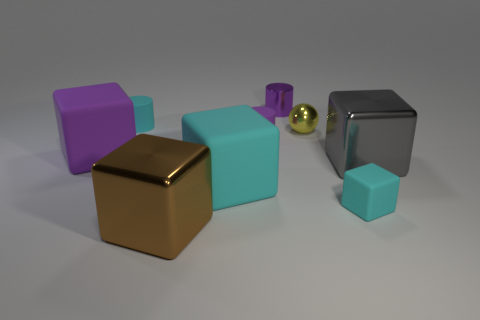Subtract all purple blocks. How many blocks are left? 4 Add 1 metal balls. How many objects exist? 10 Subtract all gray cylinders. How many cyan blocks are left? 2 Subtract all gray cubes. How many cubes are left? 4 Subtract 5 blocks. How many blocks are left? 0 Subtract all cylinders. How many objects are left? 6 Subtract all big gray cylinders. Subtract all spheres. How many objects are left? 8 Add 8 brown metallic things. How many brown metallic things are left? 9 Add 1 yellow shiny things. How many yellow shiny things exist? 2 Subtract 1 cyan cylinders. How many objects are left? 8 